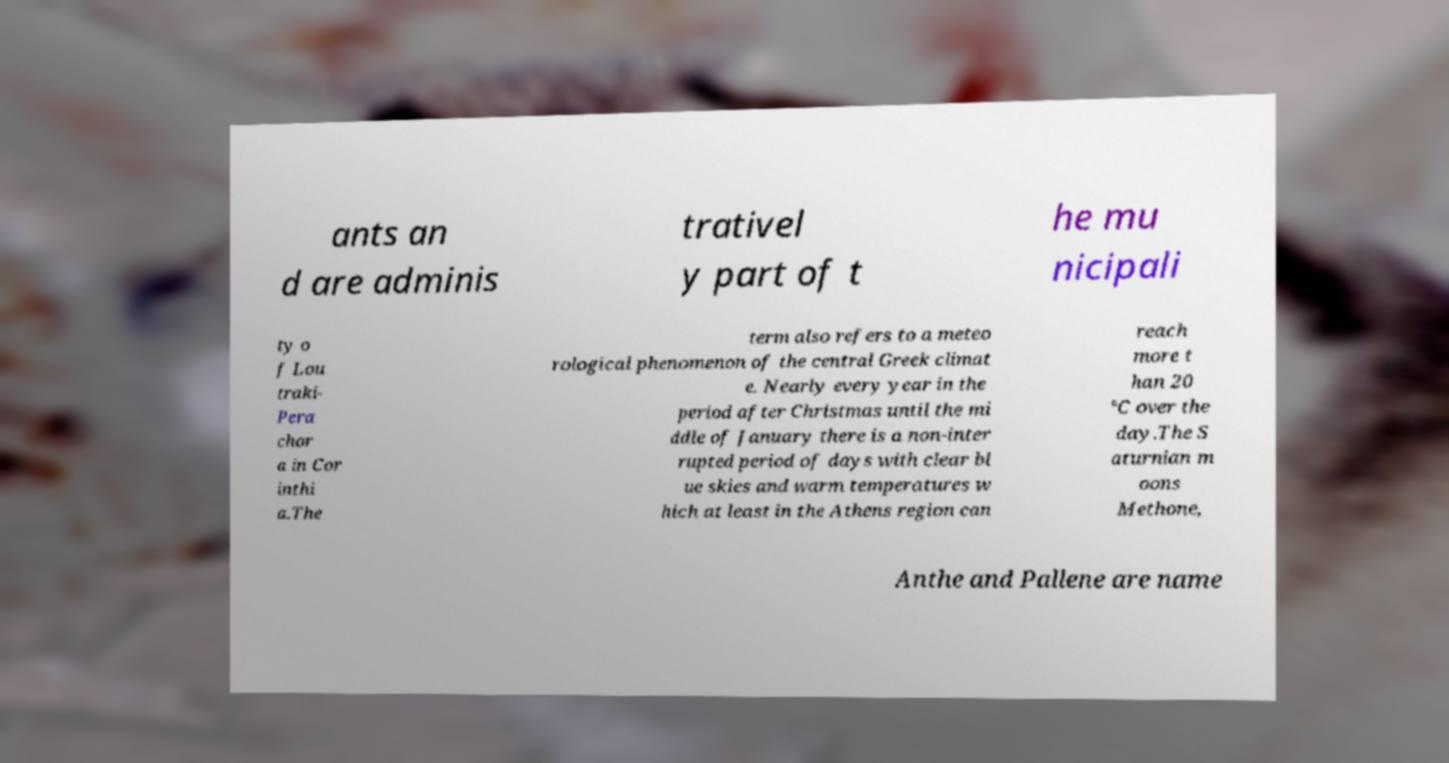Can you read and provide the text displayed in the image?This photo seems to have some interesting text. Can you extract and type it out for me? ants an d are adminis trativel y part of t he mu nicipali ty o f Lou traki- Pera chor a in Cor inthi a.The term also refers to a meteo rological phenomenon of the central Greek climat e. Nearly every year in the period after Christmas until the mi ddle of January there is a non-inter rupted period of days with clear bl ue skies and warm temperatures w hich at least in the Athens region can reach more t han 20 °C over the day.The S aturnian m oons Methone, Anthe and Pallene are name 